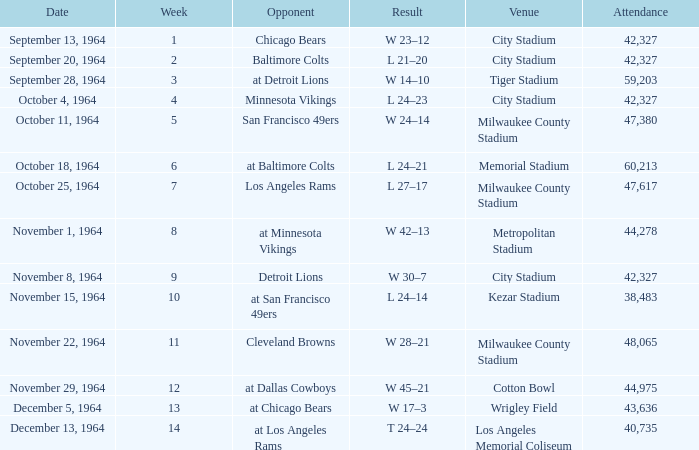What is the average attendance at a week 4 game? 42327.0. 